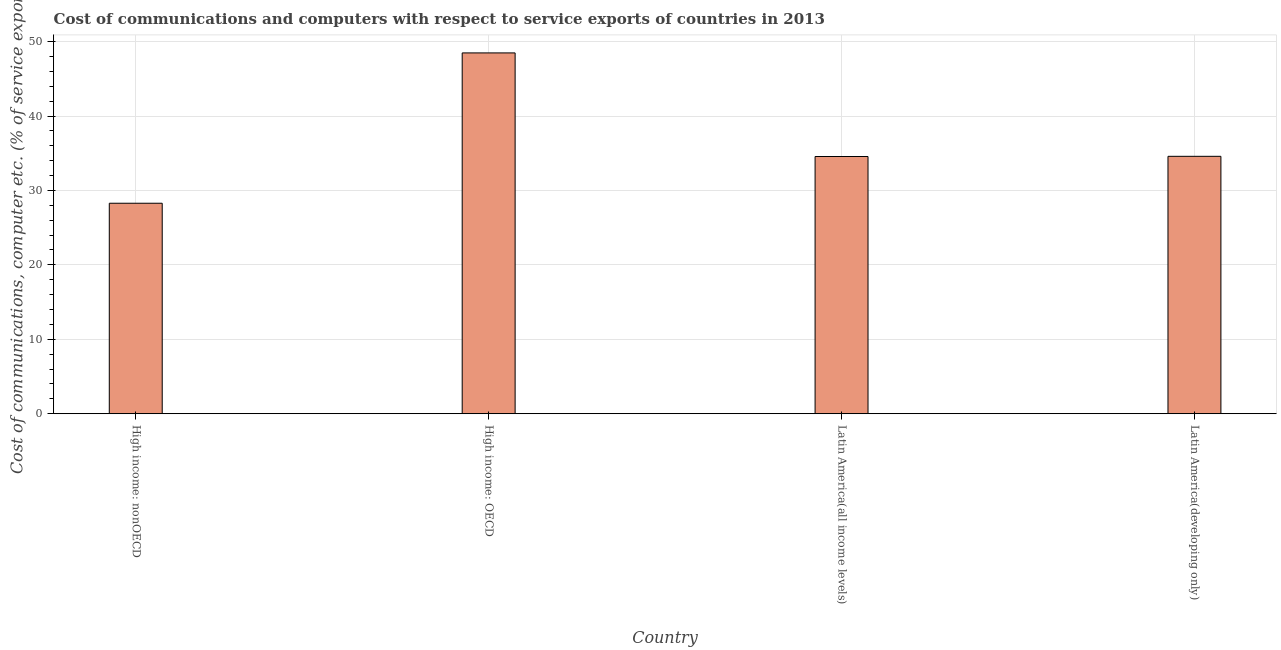Does the graph contain any zero values?
Ensure brevity in your answer.  No. Does the graph contain grids?
Your answer should be very brief. Yes. What is the title of the graph?
Your answer should be compact. Cost of communications and computers with respect to service exports of countries in 2013. What is the label or title of the X-axis?
Provide a short and direct response. Country. What is the label or title of the Y-axis?
Offer a terse response. Cost of communications, computer etc. (% of service exports). What is the cost of communications and computer in Latin America(developing only)?
Your response must be concise. 34.58. Across all countries, what is the maximum cost of communications and computer?
Provide a short and direct response. 48.48. Across all countries, what is the minimum cost of communications and computer?
Your response must be concise. 28.28. In which country was the cost of communications and computer maximum?
Ensure brevity in your answer.  High income: OECD. In which country was the cost of communications and computer minimum?
Ensure brevity in your answer.  High income: nonOECD. What is the sum of the cost of communications and computer?
Make the answer very short. 145.9. What is the difference between the cost of communications and computer in High income: OECD and Latin America(developing only)?
Your response must be concise. 13.89. What is the average cost of communications and computer per country?
Offer a terse response. 36.48. What is the median cost of communications and computer?
Give a very brief answer. 34.57. What is the ratio of the cost of communications and computer in High income: nonOECD to that in Latin America(all income levels)?
Keep it short and to the point. 0.82. Is the difference between the cost of communications and computer in High income: nonOECD and Latin America(all income levels) greater than the difference between any two countries?
Provide a succinct answer. No. What is the difference between the highest and the second highest cost of communications and computer?
Give a very brief answer. 13.89. Is the sum of the cost of communications and computer in High income: OECD and High income: nonOECD greater than the maximum cost of communications and computer across all countries?
Provide a short and direct response. Yes. What is the difference between the highest and the lowest cost of communications and computer?
Ensure brevity in your answer.  20.2. Are all the bars in the graph horizontal?
Offer a very short reply. No. What is the Cost of communications, computer etc. (% of service exports) in High income: nonOECD?
Your answer should be very brief. 28.28. What is the Cost of communications, computer etc. (% of service exports) in High income: OECD?
Offer a very short reply. 48.48. What is the Cost of communications, computer etc. (% of service exports) in Latin America(all income levels)?
Your response must be concise. 34.56. What is the Cost of communications, computer etc. (% of service exports) in Latin America(developing only)?
Keep it short and to the point. 34.58. What is the difference between the Cost of communications, computer etc. (% of service exports) in High income: nonOECD and High income: OECD?
Offer a terse response. -20.2. What is the difference between the Cost of communications, computer etc. (% of service exports) in High income: nonOECD and Latin America(all income levels)?
Offer a terse response. -6.28. What is the difference between the Cost of communications, computer etc. (% of service exports) in High income: nonOECD and Latin America(developing only)?
Provide a succinct answer. -6.3. What is the difference between the Cost of communications, computer etc. (% of service exports) in High income: OECD and Latin America(all income levels)?
Provide a short and direct response. 13.92. What is the difference between the Cost of communications, computer etc. (% of service exports) in High income: OECD and Latin America(developing only)?
Give a very brief answer. 13.89. What is the difference between the Cost of communications, computer etc. (% of service exports) in Latin America(all income levels) and Latin America(developing only)?
Offer a very short reply. -0.02. What is the ratio of the Cost of communications, computer etc. (% of service exports) in High income: nonOECD to that in High income: OECD?
Your answer should be very brief. 0.58. What is the ratio of the Cost of communications, computer etc. (% of service exports) in High income: nonOECD to that in Latin America(all income levels)?
Your answer should be very brief. 0.82. What is the ratio of the Cost of communications, computer etc. (% of service exports) in High income: nonOECD to that in Latin America(developing only)?
Provide a succinct answer. 0.82. What is the ratio of the Cost of communications, computer etc. (% of service exports) in High income: OECD to that in Latin America(all income levels)?
Your answer should be compact. 1.4. What is the ratio of the Cost of communications, computer etc. (% of service exports) in High income: OECD to that in Latin America(developing only)?
Offer a very short reply. 1.4. 